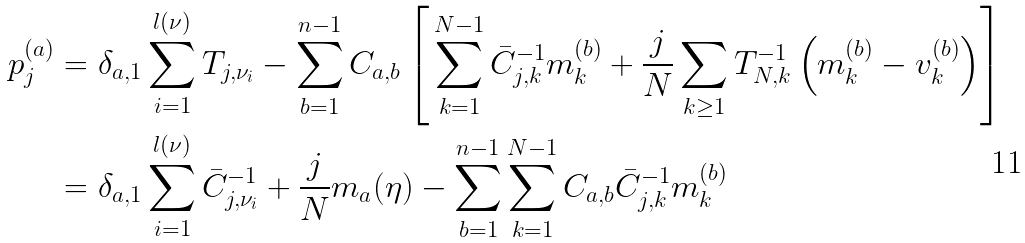<formula> <loc_0><loc_0><loc_500><loc_500>p _ { j } ^ { ( a ) } & = \delta _ { a , 1 } \sum _ { i = 1 } ^ { l ( \nu ) } T _ { j , \nu _ { i } } - \sum _ { b = 1 } ^ { n - 1 } C _ { a , b } \left [ \, \sum _ { k = 1 } ^ { N - 1 } \bar { C } ^ { - 1 } _ { j , k } m _ { k } ^ { ( b ) } + \frac { j } { N } \sum _ { k \geq 1 } T ^ { - 1 } _ { N , k } \left ( m _ { k } ^ { ( b ) } - v _ { k } ^ { ( b ) } \right ) \right ] \\ & = \delta _ { a , 1 } \sum _ { i = 1 } ^ { l ( \nu ) } \bar { C } ^ { - 1 } _ { j , \nu _ { i } } + \frac { j } { N } m _ { a } ( \eta ) - \sum _ { b = 1 } ^ { n - 1 } \sum _ { k = 1 } ^ { N - 1 } C _ { a , b } \bar { C } ^ { - 1 } _ { j , k } m _ { k } ^ { ( b ) }</formula> 